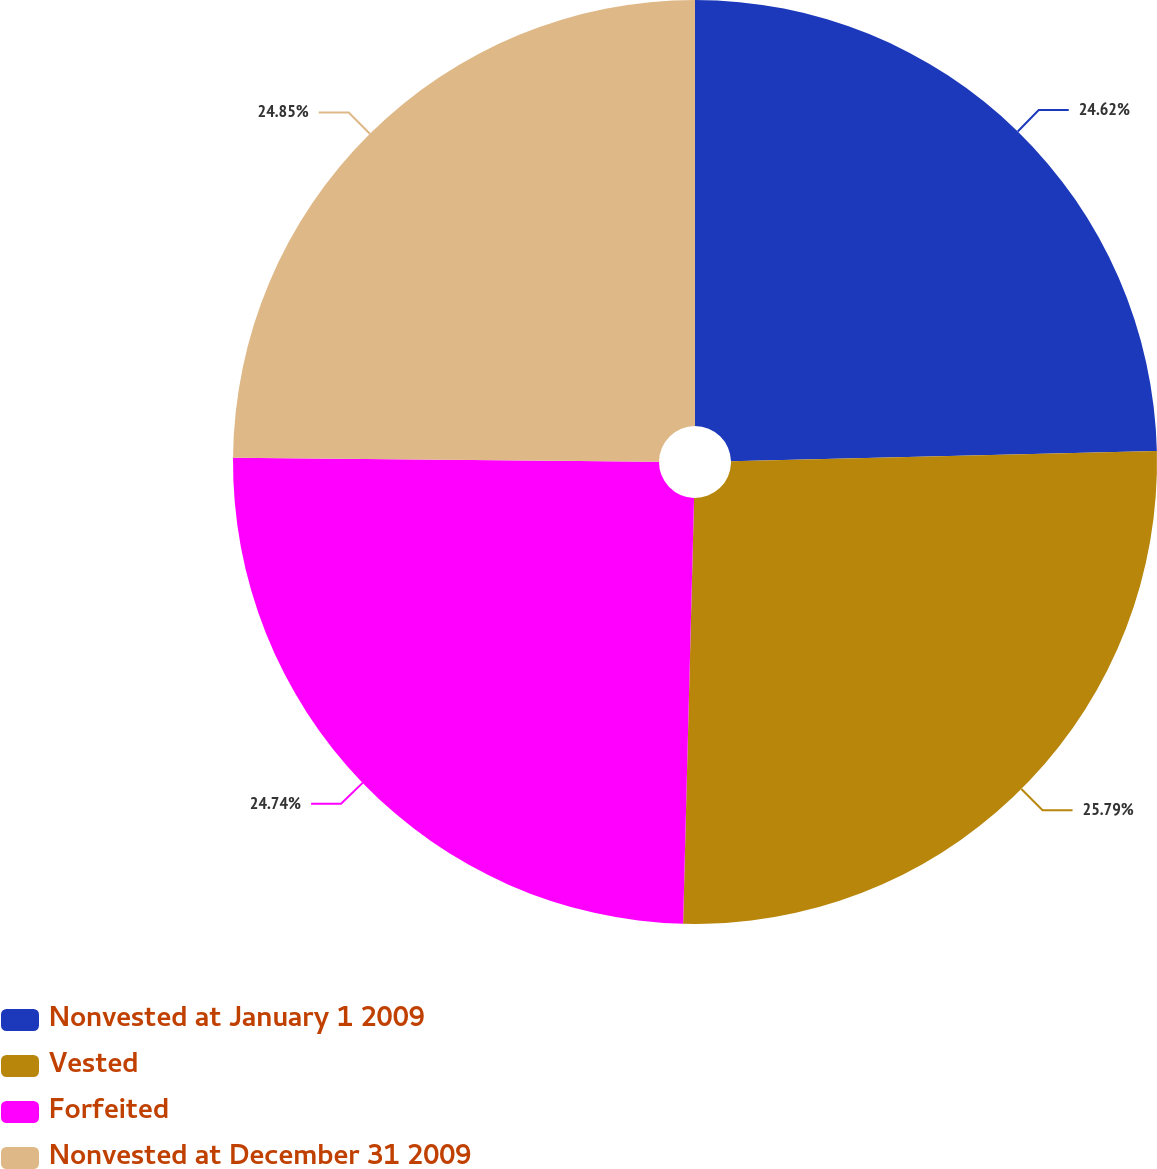Convert chart. <chart><loc_0><loc_0><loc_500><loc_500><pie_chart><fcel>Nonvested at January 1 2009<fcel>Vested<fcel>Forfeited<fcel>Nonvested at December 31 2009<nl><fcel>24.62%<fcel>25.79%<fcel>24.74%<fcel>24.85%<nl></chart> 